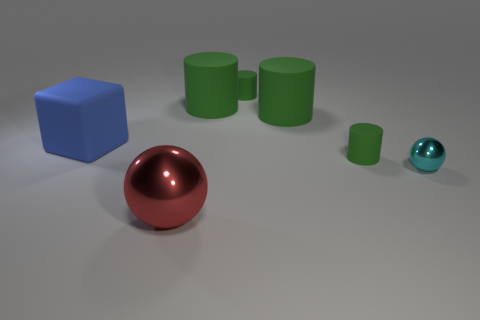Is the sphere that is on the right side of the red shiny ball made of the same material as the blue block?
Make the answer very short. No. Is the number of big red balls that are to the left of the block greater than the number of big red shiny balls right of the cyan metallic object?
Provide a succinct answer. No. There is a cube that is the same size as the red metallic sphere; what is its color?
Provide a short and direct response. Blue. Is there another shiny sphere that has the same color as the tiny metallic sphere?
Your response must be concise. No. There is a tiny rubber cylinder that is behind the large blue matte thing; is its color the same as the matte cylinder in front of the blue matte block?
Keep it short and to the point. Yes. What is the material of the tiny green cylinder that is in front of the block?
Ensure brevity in your answer.  Rubber. What is the color of the other object that is the same material as the cyan object?
Your answer should be very brief. Red. What number of cyan spheres have the same size as the red ball?
Your answer should be compact. 0. There is a green object that is in front of the blue matte object; is it the same size as the blue rubber block?
Keep it short and to the point. No. There is a thing that is both behind the cyan metal ball and in front of the blue matte thing; what shape is it?
Give a very brief answer. Cylinder. 